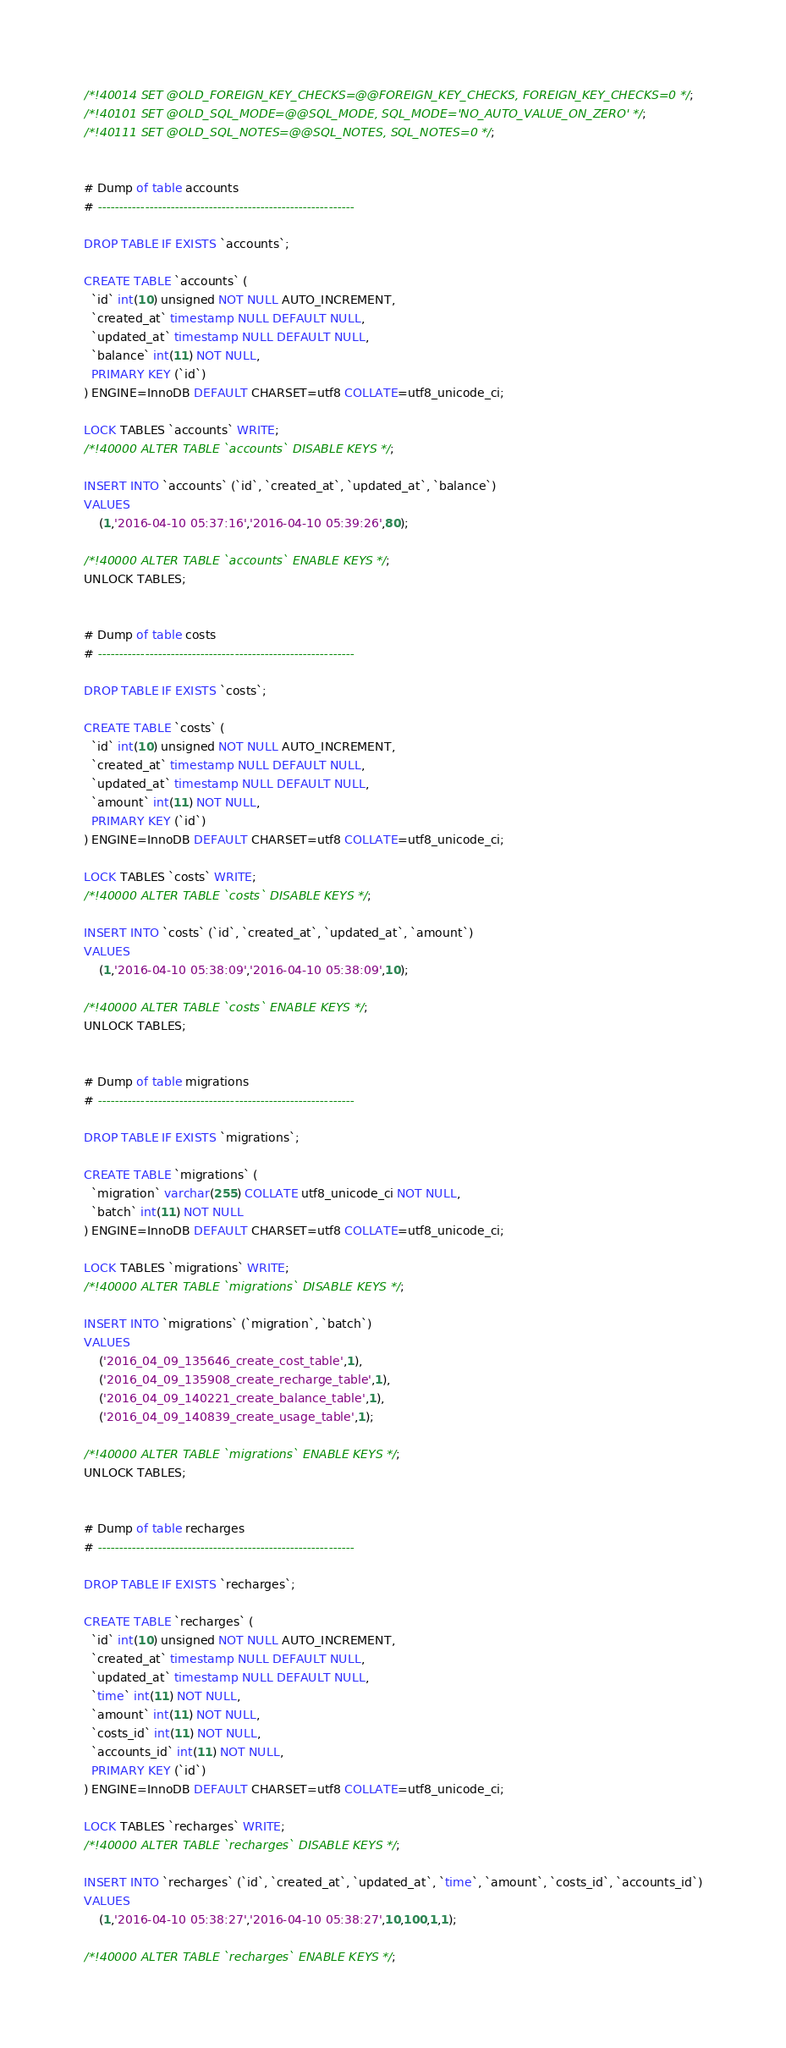Convert code to text. <code><loc_0><loc_0><loc_500><loc_500><_SQL_>/*!40014 SET @OLD_FOREIGN_KEY_CHECKS=@@FOREIGN_KEY_CHECKS, FOREIGN_KEY_CHECKS=0 */;
/*!40101 SET @OLD_SQL_MODE=@@SQL_MODE, SQL_MODE='NO_AUTO_VALUE_ON_ZERO' */;
/*!40111 SET @OLD_SQL_NOTES=@@SQL_NOTES, SQL_NOTES=0 */;


# Dump of table accounts
# ------------------------------------------------------------

DROP TABLE IF EXISTS `accounts`;

CREATE TABLE `accounts` (
  `id` int(10) unsigned NOT NULL AUTO_INCREMENT,
  `created_at` timestamp NULL DEFAULT NULL,
  `updated_at` timestamp NULL DEFAULT NULL,
  `balance` int(11) NOT NULL,
  PRIMARY KEY (`id`)
) ENGINE=InnoDB DEFAULT CHARSET=utf8 COLLATE=utf8_unicode_ci;

LOCK TABLES `accounts` WRITE;
/*!40000 ALTER TABLE `accounts` DISABLE KEYS */;

INSERT INTO `accounts` (`id`, `created_at`, `updated_at`, `balance`)
VALUES
	(1,'2016-04-10 05:37:16','2016-04-10 05:39:26',80);

/*!40000 ALTER TABLE `accounts` ENABLE KEYS */;
UNLOCK TABLES;


# Dump of table costs
# ------------------------------------------------------------

DROP TABLE IF EXISTS `costs`;

CREATE TABLE `costs` (
  `id` int(10) unsigned NOT NULL AUTO_INCREMENT,
  `created_at` timestamp NULL DEFAULT NULL,
  `updated_at` timestamp NULL DEFAULT NULL,
  `amount` int(11) NOT NULL,
  PRIMARY KEY (`id`)
) ENGINE=InnoDB DEFAULT CHARSET=utf8 COLLATE=utf8_unicode_ci;

LOCK TABLES `costs` WRITE;
/*!40000 ALTER TABLE `costs` DISABLE KEYS */;

INSERT INTO `costs` (`id`, `created_at`, `updated_at`, `amount`)
VALUES
	(1,'2016-04-10 05:38:09','2016-04-10 05:38:09',10);

/*!40000 ALTER TABLE `costs` ENABLE KEYS */;
UNLOCK TABLES;


# Dump of table migrations
# ------------------------------------------------------------

DROP TABLE IF EXISTS `migrations`;

CREATE TABLE `migrations` (
  `migration` varchar(255) COLLATE utf8_unicode_ci NOT NULL,
  `batch` int(11) NOT NULL
) ENGINE=InnoDB DEFAULT CHARSET=utf8 COLLATE=utf8_unicode_ci;

LOCK TABLES `migrations` WRITE;
/*!40000 ALTER TABLE `migrations` DISABLE KEYS */;

INSERT INTO `migrations` (`migration`, `batch`)
VALUES
	('2016_04_09_135646_create_cost_table',1),
	('2016_04_09_135908_create_recharge_table',1),
	('2016_04_09_140221_create_balance_table',1),
	('2016_04_09_140839_create_usage_table',1);

/*!40000 ALTER TABLE `migrations` ENABLE KEYS */;
UNLOCK TABLES;


# Dump of table recharges
# ------------------------------------------------------------

DROP TABLE IF EXISTS `recharges`;

CREATE TABLE `recharges` (
  `id` int(10) unsigned NOT NULL AUTO_INCREMENT,
  `created_at` timestamp NULL DEFAULT NULL,
  `updated_at` timestamp NULL DEFAULT NULL,
  `time` int(11) NOT NULL,
  `amount` int(11) NOT NULL,
  `costs_id` int(11) NOT NULL,
  `accounts_id` int(11) NOT NULL,
  PRIMARY KEY (`id`)
) ENGINE=InnoDB DEFAULT CHARSET=utf8 COLLATE=utf8_unicode_ci;

LOCK TABLES `recharges` WRITE;
/*!40000 ALTER TABLE `recharges` DISABLE KEYS */;

INSERT INTO `recharges` (`id`, `created_at`, `updated_at`, `time`, `amount`, `costs_id`, `accounts_id`)
VALUES
	(1,'2016-04-10 05:38:27','2016-04-10 05:38:27',10,100,1,1);

/*!40000 ALTER TABLE `recharges` ENABLE KEYS */;</code> 